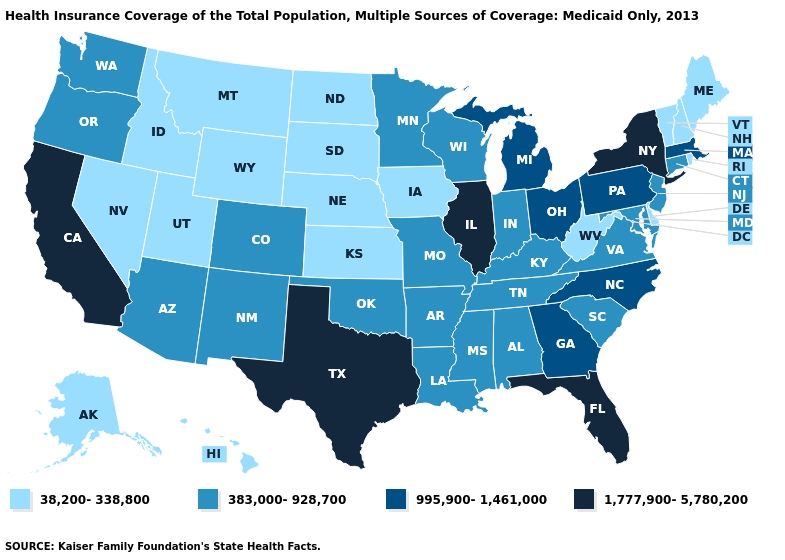What is the value of Wisconsin?
Answer briefly. 383,000-928,700. What is the value of North Dakota?
Write a very short answer. 38,200-338,800. What is the value of New Mexico?
Be succinct. 383,000-928,700. Which states hav the highest value in the Northeast?
Give a very brief answer. New York. What is the lowest value in the West?
Give a very brief answer. 38,200-338,800. Does Missouri have the highest value in the MidWest?
Write a very short answer. No. What is the highest value in states that border Alabama?
Concise answer only. 1,777,900-5,780,200. Which states hav the highest value in the South?
Concise answer only. Florida, Texas. Name the states that have a value in the range 995,900-1,461,000?
Quick response, please. Georgia, Massachusetts, Michigan, North Carolina, Ohio, Pennsylvania. Does New York have the highest value in the USA?
Write a very short answer. Yes. What is the value of North Dakota?
Short answer required. 38,200-338,800. What is the value of Virginia?
Give a very brief answer. 383,000-928,700. Among the states that border Iowa , which have the lowest value?
Write a very short answer. Nebraska, South Dakota. Does Michigan have a higher value than Pennsylvania?
Concise answer only. No. Name the states that have a value in the range 995,900-1,461,000?
Short answer required. Georgia, Massachusetts, Michigan, North Carolina, Ohio, Pennsylvania. 